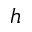<formula> <loc_0><loc_0><loc_500><loc_500>h</formula> 